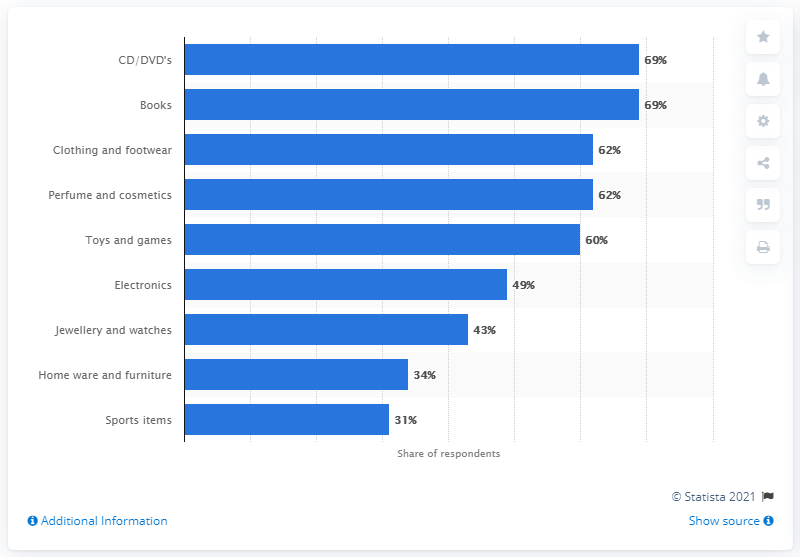Draw attention to some important aspects in this diagram. For the year 2022 in the United Kingdom, the most popular Christmas presents were jewelry and watches. 